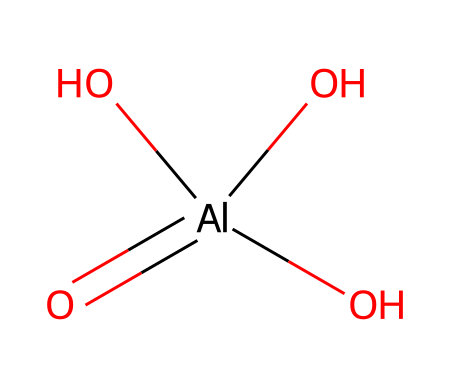What is the central atom in this compound? The representation shows aluminum (Al) at the center, surrounded by oxygen atoms, indicating that aluminum is the central atom in this compound.
Answer: aluminum How many oxygen atoms are present in the structure? By analyzing the structure, we can count four oxygen atoms bonded to the aluminum atom, therefore the number of oxygen atoms is four.
Answer: four What is the coordination number of aluminum in this compound? The aluminum atom is bonded to four oxygen atoms, which means its coordination number, reflecting the number of nearest neighbors, is four.
Answer: four What type of compound is represented by this structure? The structure indicates a metal hydroxide because all the oxygen atoms are bonded in hydroxyl form (OH groups), typical of aluminum compounds in this category.
Answer: metal hydroxide Is this compound soluble in water? Many aluminum hydroxides can form colloidal suspensions in water, suggesting that this compound would likely show some degree of solubility or reactivity in water.
Answer: yes What does the presence of hydroxyl groups suggest about the compound's reactivity? Hydroxyl groups generally indicate a higher potential for reactivity with acids, forming salts; thus, the presence of these groups suggests that the compound can engage in acid-base reactions.
Answer: high reactivity 